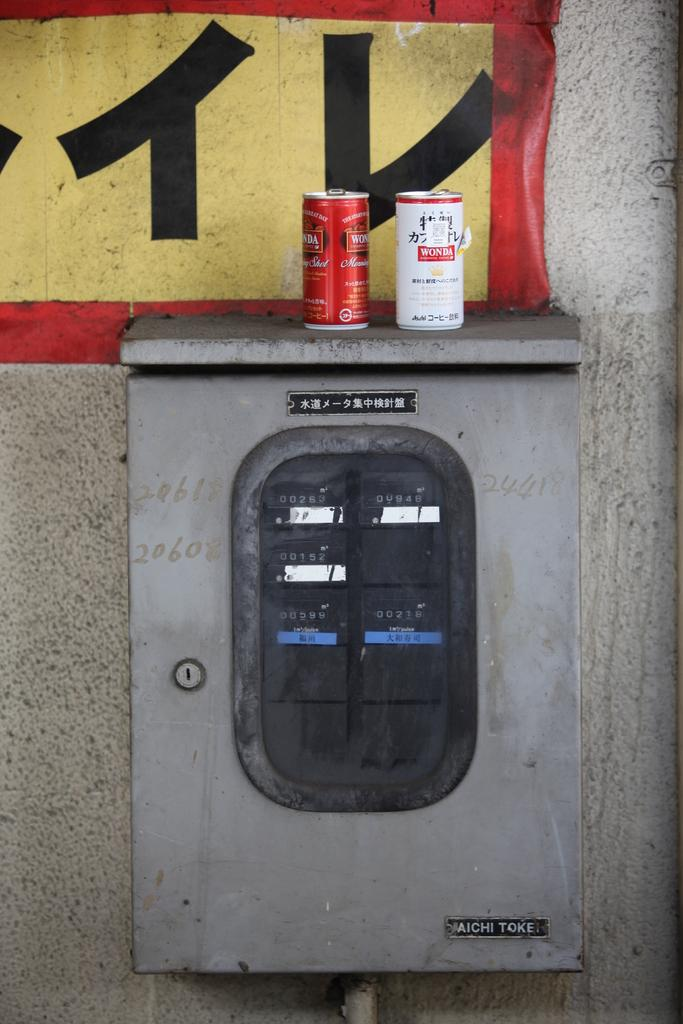<image>
Relay a brief, clear account of the picture shown. a couple of cans with one that says wonda on it 